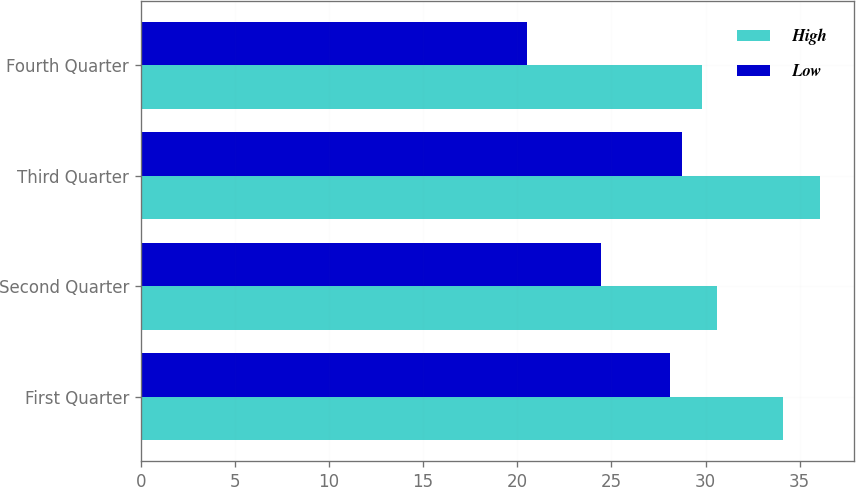Convert chart. <chart><loc_0><loc_0><loc_500><loc_500><stacked_bar_chart><ecel><fcel>First Quarter<fcel>Second Quarter<fcel>Third Quarter<fcel>Fourth Quarter<nl><fcel>High<fcel>34.13<fcel>30.6<fcel>36.09<fcel>29.83<nl><fcel>Low<fcel>28.1<fcel>24.46<fcel>28.74<fcel>20.53<nl></chart> 